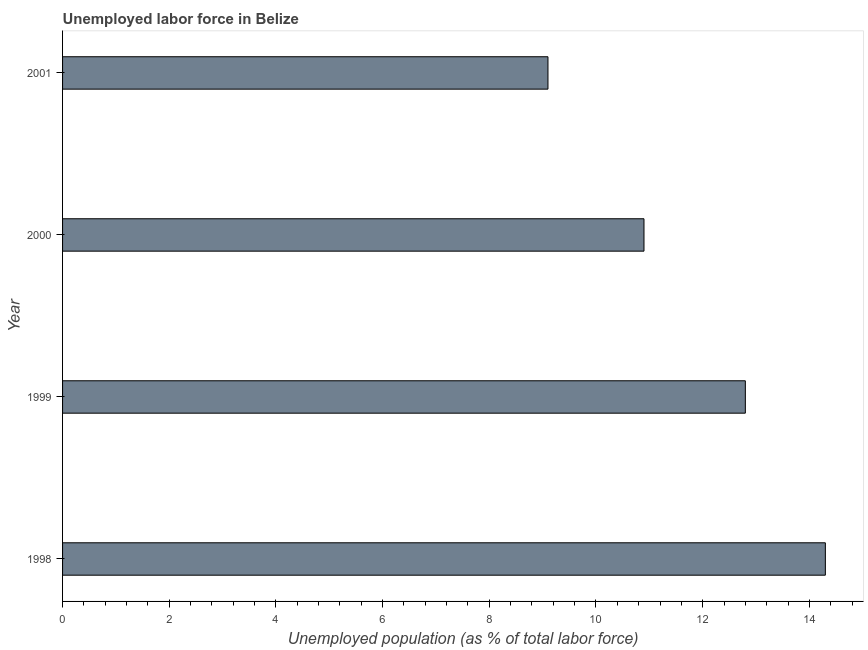What is the title of the graph?
Make the answer very short. Unemployed labor force in Belize. What is the label or title of the X-axis?
Offer a very short reply. Unemployed population (as % of total labor force). What is the total unemployed population in 2001?
Provide a succinct answer. 9.1. Across all years, what is the maximum total unemployed population?
Ensure brevity in your answer.  14.3. Across all years, what is the minimum total unemployed population?
Give a very brief answer. 9.1. In which year was the total unemployed population maximum?
Ensure brevity in your answer.  1998. What is the sum of the total unemployed population?
Offer a very short reply. 47.1. What is the difference between the total unemployed population in 1999 and 2000?
Offer a terse response. 1.9. What is the average total unemployed population per year?
Provide a succinct answer. 11.78. What is the median total unemployed population?
Your answer should be compact. 11.85. In how many years, is the total unemployed population greater than 8.8 %?
Your response must be concise. 4. What is the ratio of the total unemployed population in 1998 to that in 1999?
Your answer should be very brief. 1.12. Is the difference between the total unemployed population in 1998 and 2000 greater than the difference between any two years?
Ensure brevity in your answer.  No. Is the sum of the total unemployed population in 1999 and 2001 greater than the maximum total unemployed population across all years?
Ensure brevity in your answer.  Yes. In how many years, is the total unemployed population greater than the average total unemployed population taken over all years?
Provide a succinct answer. 2. How many bars are there?
Your answer should be very brief. 4. What is the difference between two consecutive major ticks on the X-axis?
Your response must be concise. 2. What is the Unemployed population (as % of total labor force) of 1998?
Ensure brevity in your answer.  14.3. What is the Unemployed population (as % of total labor force) of 1999?
Provide a succinct answer. 12.8. What is the Unemployed population (as % of total labor force) of 2000?
Provide a succinct answer. 10.9. What is the Unemployed population (as % of total labor force) in 2001?
Your answer should be compact. 9.1. What is the difference between the Unemployed population (as % of total labor force) in 1999 and 2001?
Give a very brief answer. 3.7. What is the ratio of the Unemployed population (as % of total labor force) in 1998 to that in 1999?
Your answer should be very brief. 1.12. What is the ratio of the Unemployed population (as % of total labor force) in 1998 to that in 2000?
Ensure brevity in your answer.  1.31. What is the ratio of the Unemployed population (as % of total labor force) in 1998 to that in 2001?
Offer a very short reply. 1.57. What is the ratio of the Unemployed population (as % of total labor force) in 1999 to that in 2000?
Provide a succinct answer. 1.17. What is the ratio of the Unemployed population (as % of total labor force) in 1999 to that in 2001?
Your answer should be very brief. 1.41. What is the ratio of the Unemployed population (as % of total labor force) in 2000 to that in 2001?
Your response must be concise. 1.2. 